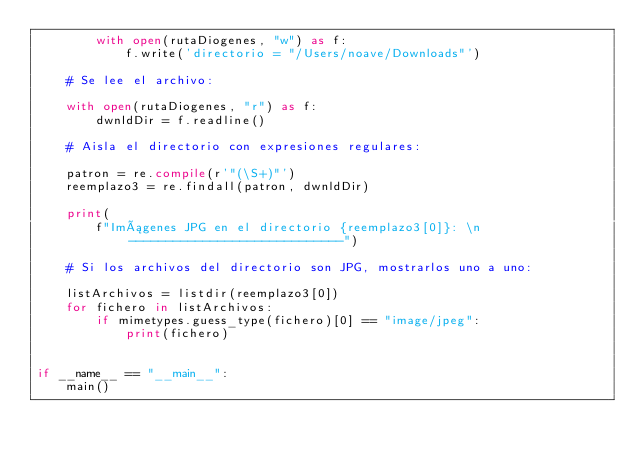Convert code to text. <code><loc_0><loc_0><loc_500><loc_500><_Python_>        with open(rutaDiogenes, "w") as f:
            f.write('directorio = "/Users/noave/Downloads"')

    # Se lee el archivo:

    with open(rutaDiogenes, "r") as f:
        dwnldDir = f.readline()

    # Aisla el directorio con expresiones regulares:

    patron = re.compile(r'"(\S+)"')
    reemplazo3 = re.findall(patron, dwnldDir)

    print(
        f"Imágenes JPG en el directorio {reemplazo3[0]}: \n-----------------------------")

    # Si los archivos del directorio son JPG, mostrarlos uno a uno:

    listArchivos = listdir(reemplazo3[0])
    for fichero in listArchivos:
        if mimetypes.guess_type(fichero)[0] == "image/jpeg":
            print(fichero)


if __name__ == "__main__":
    main()
</code> 